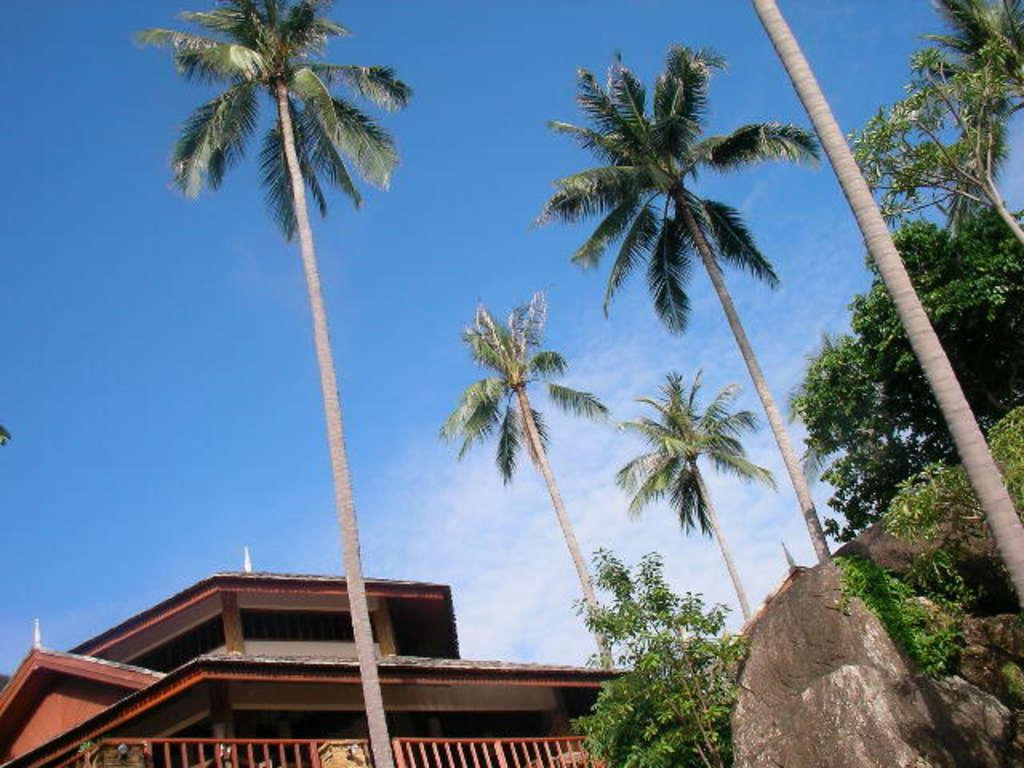What is the largest object in the image? There is a huge rock in the image. What type of vegetation is present in the image? There is grass and trees in the image. What is the color of the building in the image? The building in the image is brown-colored. What can be seen in the background of the image? The sky is visible in the background of the image. How many needles are sticking out of the huge rock in the image? There are no needles present in the image, as it features a huge rock, grass, trees, a brown-colored building, and the sky. What type of playground equipment can be seen in the image? There is no playground equipment present in the image. 